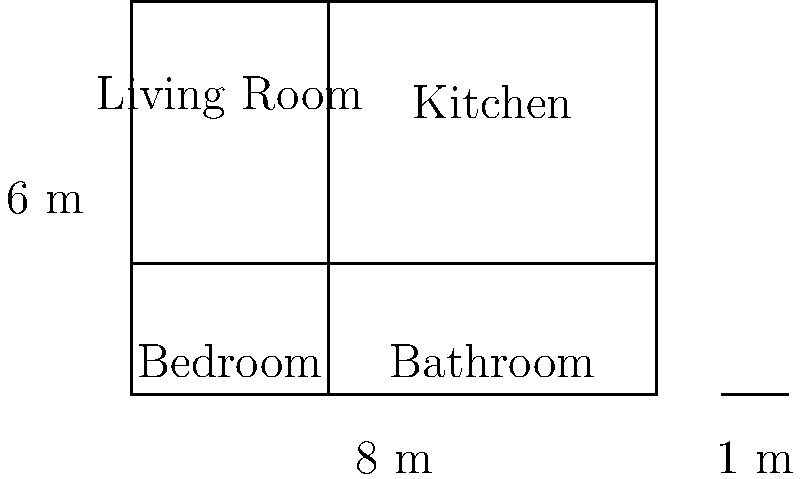As a real estate agent, you're presented with this architectural blueprint of a small apartment. The living room and kitchen share an open concept space. If a potential buyer asks about the total floor area of the open concept space (living room and kitchen combined), what would be your response? To calculate the total floor area of the open concept space (living room and kitchen combined), we need to follow these steps:

1. Identify the relevant dimensions:
   - The total width of the apartment is 8 meters
   - The total height of the apartment is 6 meters
   - The dividing line for the bedroom and bathroom is at 2 meters from the bottom

2. Calculate the area of the open concept space:
   - The width remains the full 8 meters
   - The height is the remaining space above the bedroom and bathroom, which is 4 meters (6m - 2m)

3. Apply the area formula for a rectangle:
   $$ A = w \times h $$
   Where $A$ is area, $w$ is width, and $h$ is height

4. Plug in the values:
   $$ A = 8 \text{ m} \times 4 \text{ m} = 32 \text{ m}^2 $$

Therefore, the total floor area of the open concept space (living room and kitchen combined) is 32 square meters.
Answer: 32 m² 